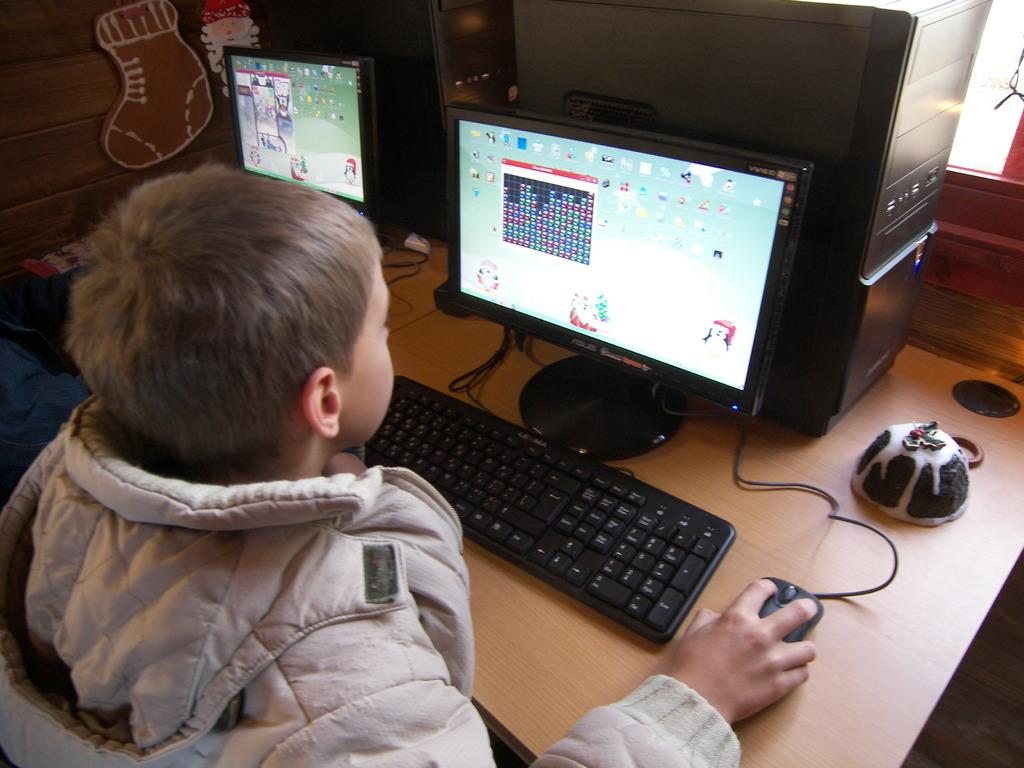What is the person in the image doing? The person is playing a game on a computer. Where is the computer located in the image? The computer is on a table. Can you describe the activity the person is engaged in? The person is playing a game on the computer. What type of bells can be heard ringing in the image? There are no bells present in the image, and therefore no sound can be heard. 